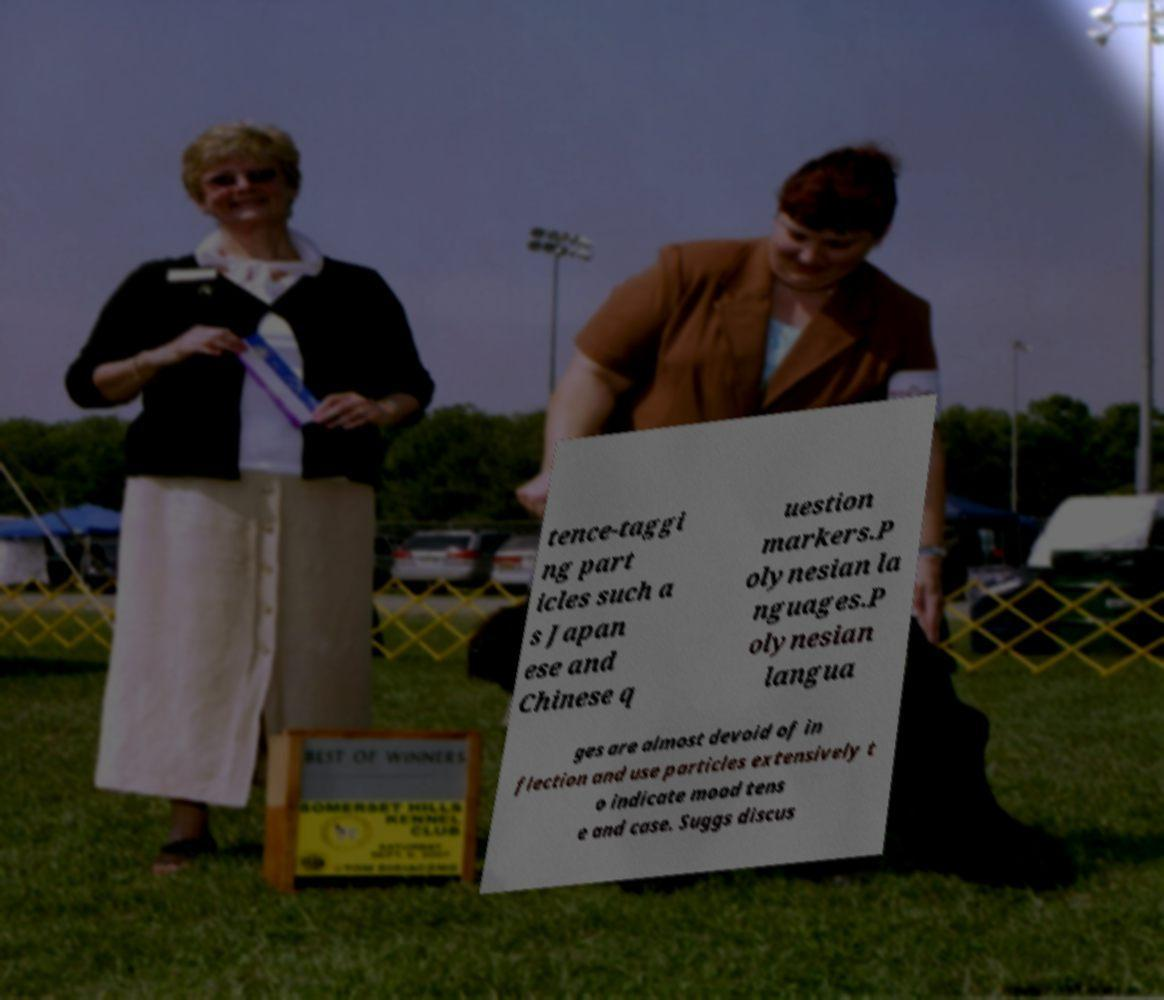What messages or text are displayed in this image? I need them in a readable, typed format. tence-taggi ng part icles such a s Japan ese and Chinese q uestion markers.P olynesian la nguages.P olynesian langua ges are almost devoid of in flection and use particles extensively t o indicate mood tens e and case. Suggs discus 